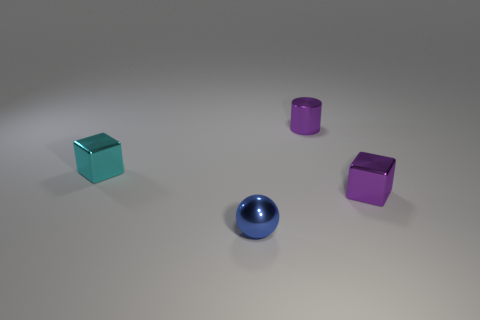Add 1 gray shiny cubes. How many objects exist? 5 Subtract all balls. How many objects are left? 3 Subtract 1 cyan blocks. How many objects are left? 3 Subtract 1 cylinders. How many cylinders are left? 0 Subtract all brown cylinders. Subtract all purple spheres. How many cylinders are left? 1 Subtract all green balls. How many cyan cubes are left? 1 Subtract all spheres. Subtract all tiny purple objects. How many objects are left? 1 Add 4 blue spheres. How many blue spheres are left? 5 Add 2 tiny cyan cubes. How many tiny cyan cubes exist? 3 